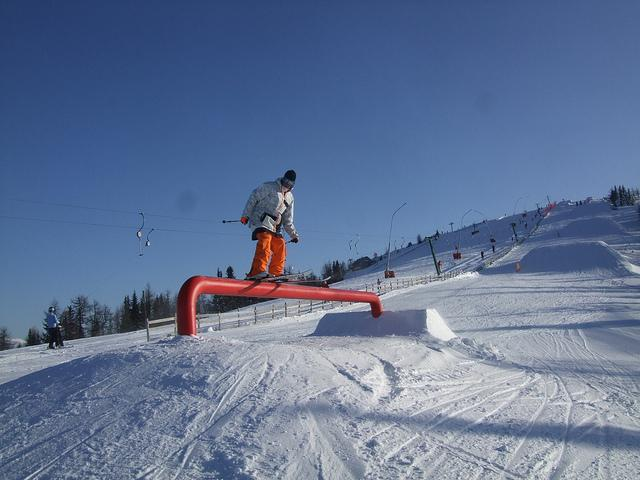What is the man going to do next? Please explain your reasoning. jumping off. The skier is beginning to crouch to jump off the rail. 